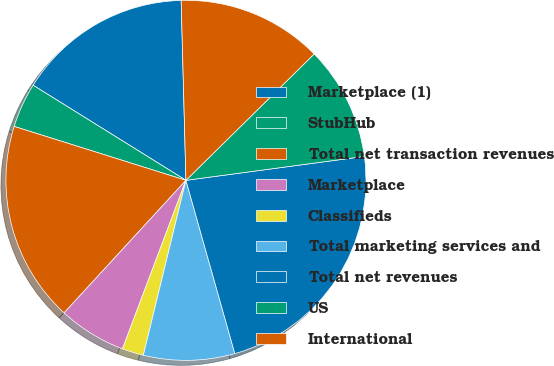Convert chart to OTSL. <chart><loc_0><loc_0><loc_500><loc_500><pie_chart><fcel>Marketplace (1)<fcel>StubHub<fcel>Total net transaction revenues<fcel>Marketplace<fcel>Classifieds<fcel>Total marketing services and<fcel>Total net revenues<fcel>US<fcel>International<nl><fcel>15.72%<fcel>4.02%<fcel>18.01%<fcel>6.1%<fcel>1.93%<fcel>8.18%<fcel>22.75%<fcel>10.26%<fcel>13.04%<nl></chart> 